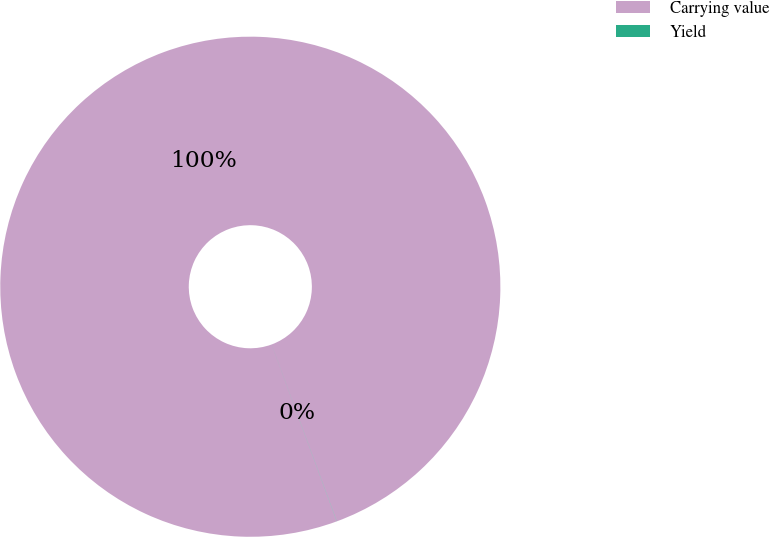Convert chart. <chart><loc_0><loc_0><loc_500><loc_500><pie_chart><fcel>Carrying value<fcel>Yield<nl><fcel>99.99%<fcel>0.01%<nl></chart> 